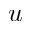Convert formula to latex. <formula><loc_0><loc_0><loc_500><loc_500>u</formula> 